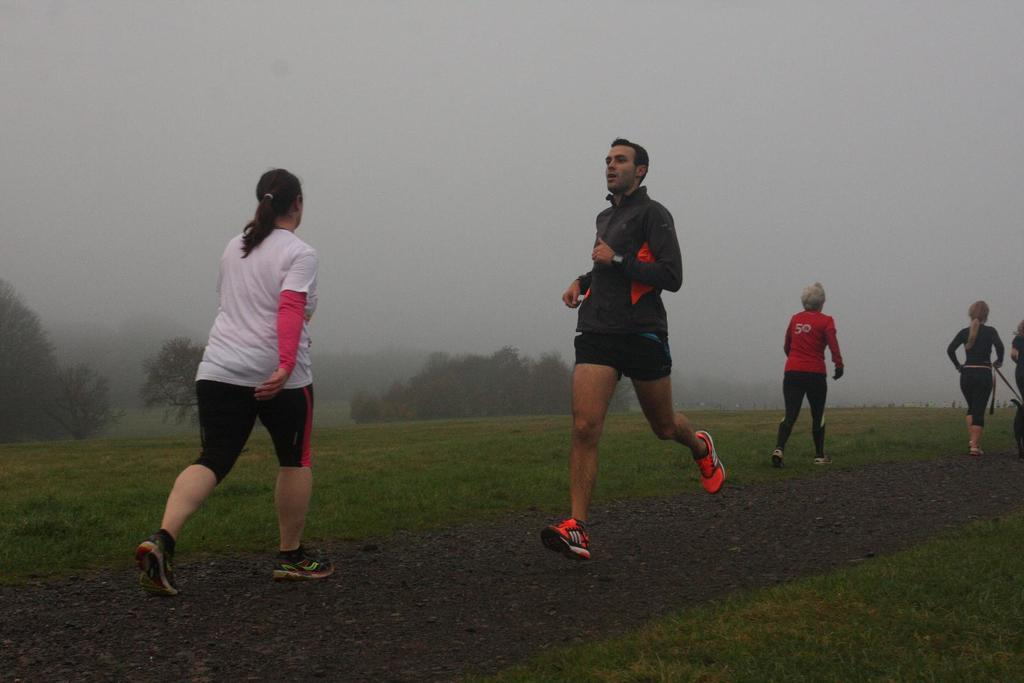What are the four persons in the image doing? The four persons in the image are running. What type of terrain can be seen at the bottom of the image? There is grass at the bottom of the image. What can be seen in the background of the image? There are trees and fog in the background of the image. What is visible at the top of the image? The sky is visible at the top of the image. What type of question is being asked by the committee in the image? There is no committee present in the image, and therefore no question is being asked. 